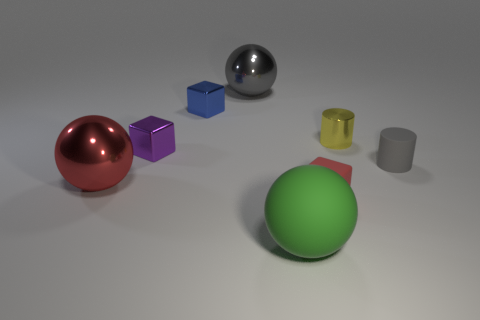Do the tiny cube to the right of the large green object and the shiny object that is in front of the tiny gray object have the same color?
Provide a short and direct response. Yes. There is a ball that is behind the tiny blue metallic block; is it the same color as the tiny matte cylinder?
Provide a short and direct response. Yes. What material is the thing that is both in front of the big gray object and behind the tiny shiny cylinder?
Provide a short and direct response. Metal. Are there any green cylinders that have the same size as the red metal ball?
Provide a succinct answer. No. What number of yellow matte cubes are there?
Your answer should be compact. 0. There is a rubber cylinder; how many large green matte objects are in front of it?
Ensure brevity in your answer.  1. Is the material of the tiny yellow object the same as the blue block?
Give a very brief answer. Yes. What number of metal balls are left of the blue cube and behind the blue block?
Make the answer very short. 0. What number of other objects are the same color as the metallic cylinder?
Provide a succinct answer. 0. What number of blue things are either big metal things or cylinders?
Your response must be concise. 0. 